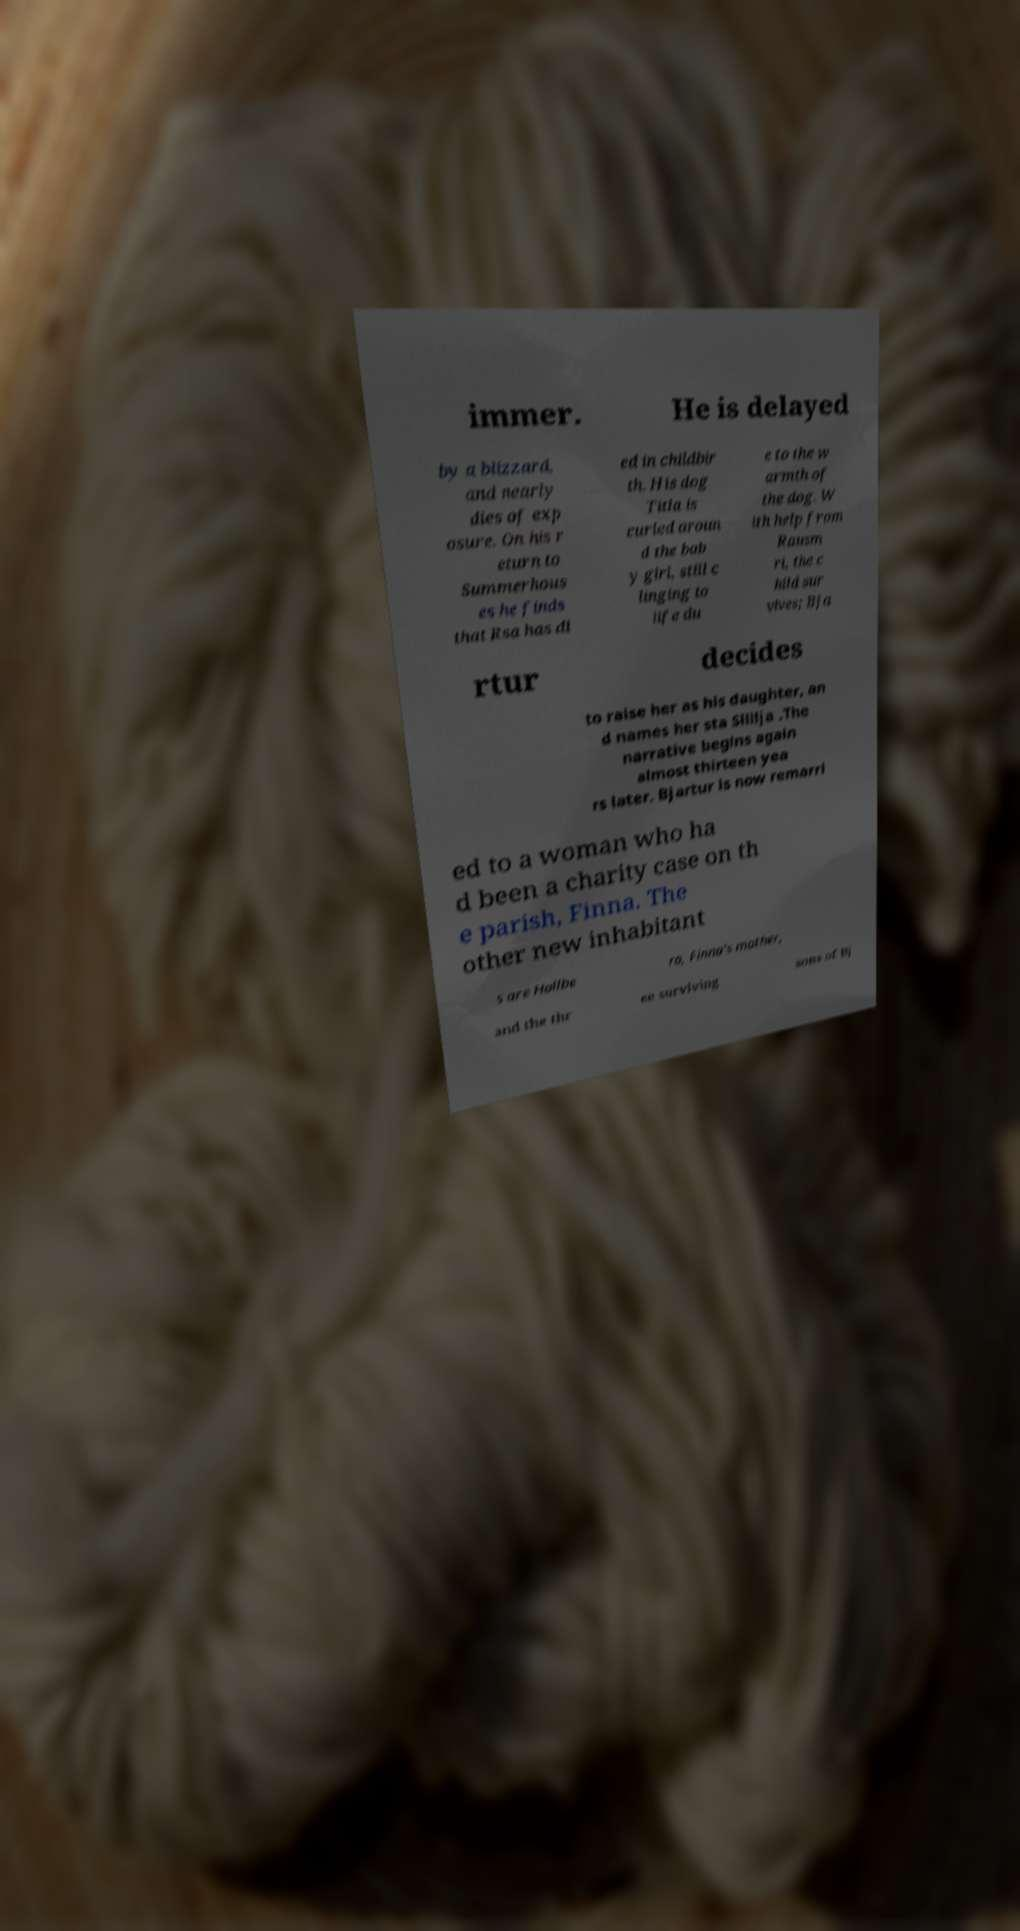For documentation purposes, I need the text within this image transcribed. Could you provide that? immer. He is delayed by a blizzard, and nearly dies of exp osure. On his r eturn to Summerhous es he finds that Rsa has di ed in childbir th. His dog Titla is curled aroun d the bab y girl, still c linging to life du e to the w armth of the dog. W ith help from Rausm ri, the c hild sur vives; Bja rtur decides to raise her as his daughter, an d names her sta Sllilja .The narrative begins again almost thirteen yea rs later. Bjartur is now remarri ed to a woman who ha d been a charity case on th e parish, Finna. The other new inhabitant s are Hallbe ra, Finna's mother, and the thr ee surviving sons of Bj 